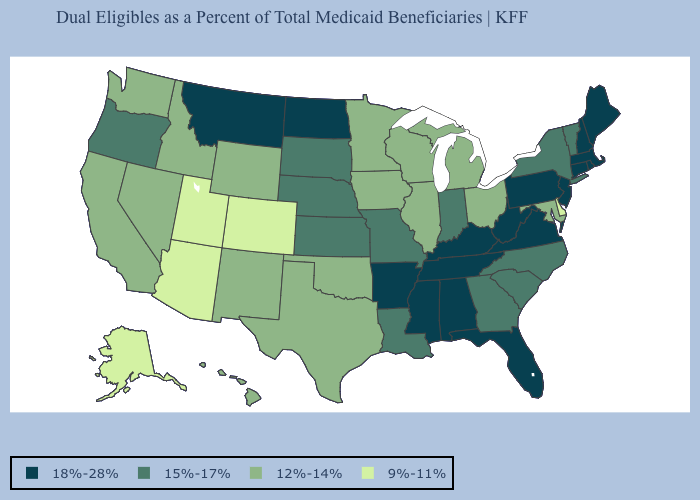Does Illinois have the highest value in the MidWest?
Answer briefly. No. Which states have the lowest value in the MidWest?
Be succinct. Illinois, Iowa, Michigan, Minnesota, Ohio, Wisconsin. What is the value of New Mexico?
Short answer required. 12%-14%. What is the value of Virginia?
Be succinct. 18%-28%. What is the lowest value in states that border Wyoming?
Short answer required. 9%-11%. What is the value of New Jersey?
Short answer required. 18%-28%. Does the map have missing data?
Keep it brief. No. Which states have the lowest value in the USA?
Keep it brief. Alaska, Arizona, Colorado, Delaware, Utah. Does Maine have the highest value in the USA?
Concise answer only. Yes. How many symbols are there in the legend?
Answer briefly. 4. Name the states that have a value in the range 12%-14%?
Give a very brief answer. California, Hawaii, Idaho, Illinois, Iowa, Maryland, Michigan, Minnesota, Nevada, New Mexico, Ohio, Oklahoma, Texas, Washington, Wisconsin, Wyoming. What is the value of West Virginia?
Short answer required. 18%-28%. Does New York have a lower value than New Hampshire?
Concise answer only. Yes. Name the states that have a value in the range 15%-17%?
Keep it brief. Georgia, Indiana, Kansas, Louisiana, Missouri, Nebraska, New York, North Carolina, Oregon, South Carolina, South Dakota, Vermont. 